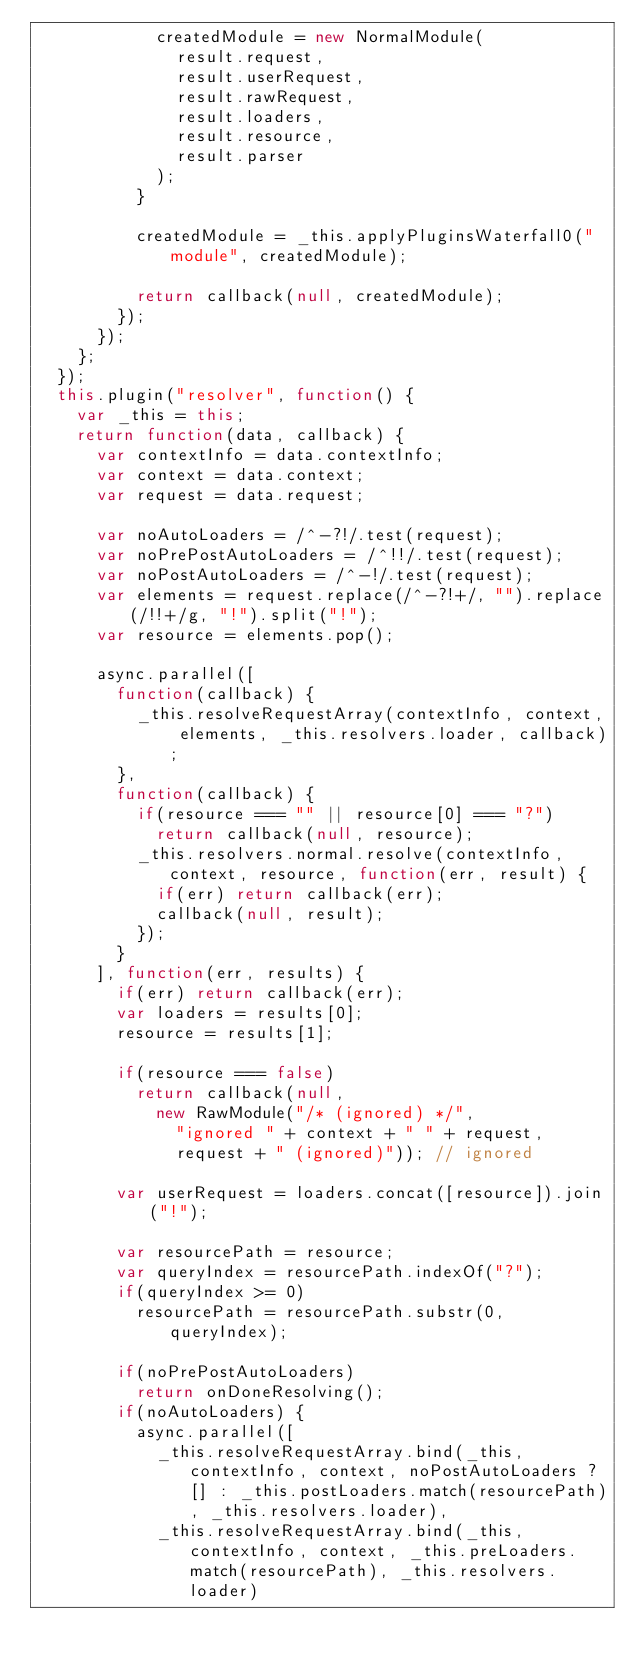<code> <loc_0><loc_0><loc_500><loc_500><_JavaScript_>						createdModule = new NormalModule(
							result.request,
							result.userRequest,
							result.rawRequest,
							result.loaders,
							result.resource,
							result.parser
						);
					}

					createdModule = _this.applyPluginsWaterfall0("module", createdModule);

					return callback(null, createdModule);
				});
			});
		};
	});
	this.plugin("resolver", function() {
		var _this = this;
		return function(data, callback) {
			var contextInfo = data.contextInfo;
			var context = data.context;
			var request = data.request;

			var noAutoLoaders = /^-?!/.test(request);
			var noPrePostAutoLoaders = /^!!/.test(request);
			var noPostAutoLoaders = /^-!/.test(request);
			var elements = request.replace(/^-?!+/, "").replace(/!!+/g, "!").split("!");
			var resource = elements.pop();

			async.parallel([
				function(callback) {
					_this.resolveRequestArray(contextInfo, context, elements, _this.resolvers.loader, callback);
				},
				function(callback) {
					if(resource === "" || resource[0] === "?")
						return callback(null, resource);
					_this.resolvers.normal.resolve(contextInfo, context, resource, function(err, result) {
						if(err) return callback(err);
						callback(null, result);
					});
				}
			], function(err, results) {
				if(err) return callback(err);
				var loaders = results[0];
				resource = results[1];

				if(resource === false)
					return callback(null,
						new RawModule("/* (ignored) */",
							"ignored " + context + " " + request,
							request + " (ignored)")); // ignored

				var userRequest = loaders.concat([resource]).join("!");

				var resourcePath = resource;
				var queryIndex = resourcePath.indexOf("?");
				if(queryIndex >= 0)
					resourcePath = resourcePath.substr(0, queryIndex);

				if(noPrePostAutoLoaders)
					return onDoneResolving();
				if(noAutoLoaders) {
					async.parallel([
						_this.resolveRequestArray.bind(_this, contextInfo, context, noPostAutoLoaders ? [] : _this.postLoaders.match(resourcePath), _this.resolvers.loader),
						_this.resolveRequestArray.bind(_this, contextInfo, context, _this.preLoaders.match(resourcePath), _this.resolvers.loader)</code> 